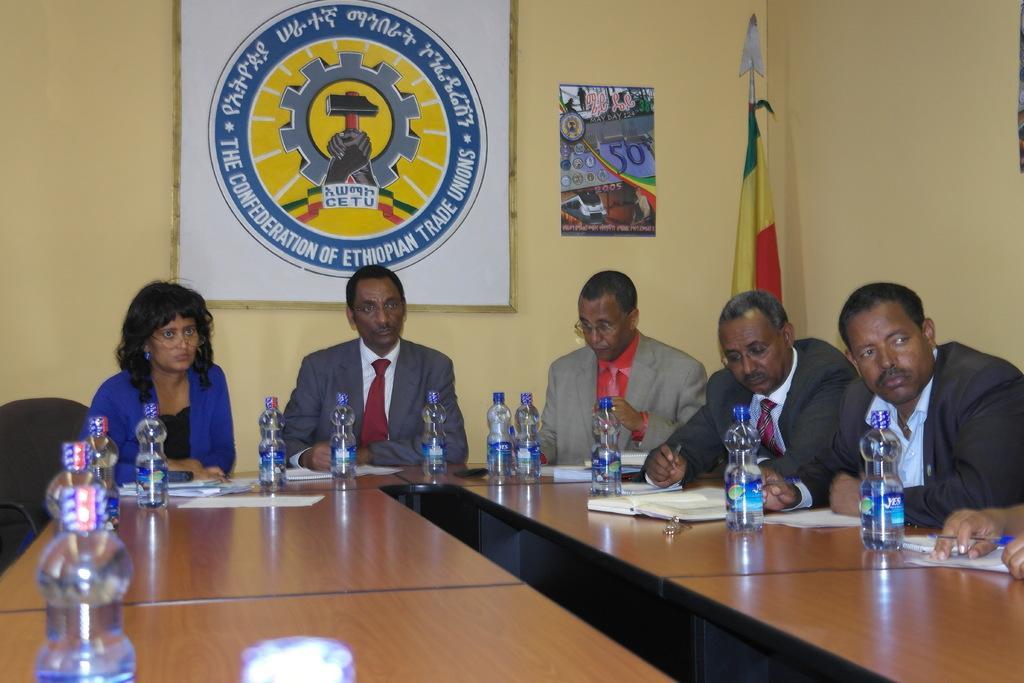How would you summarize this image in a sentence or two? In this image we can see four men and one woman is sitting. In front of them table is there, on table bottles and papers are present. The men are wearing suits and the woman is wearing blue color coat. Behind yellow color wall is there and one white color frame is attached to the wall. To the corner of the room one flag is there. 